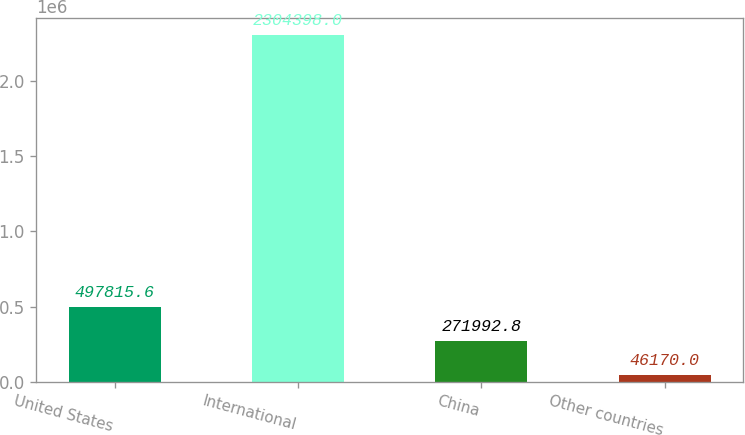Convert chart. <chart><loc_0><loc_0><loc_500><loc_500><bar_chart><fcel>United States<fcel>International<fcel>China<fcel>Other countries<nl><fcel>497816<fcel>2.3044e+06<fcel>271993<fcel>46170<nl></chart> 